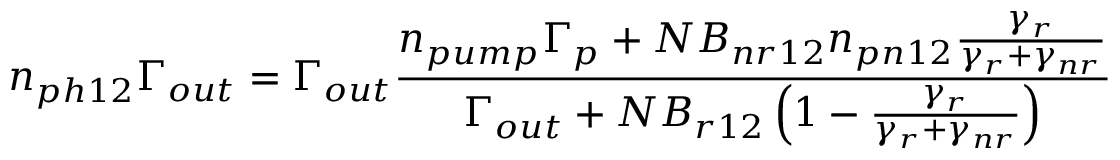<formula> <loc_0><loc_0><loc_500><loc_500>n _ { p h 1 2 } \Gamma _ { o u t } = \Gamma _ { o u t } \frac { n _ { p u m p } \Gamma _ { p } + N B _ { n r 1 2 } n _ { p n 1 2 } \frac { \gamma _ { r } } { \gamma _ { r } + \gamma _ { n r } } } { \Gamma _ { o u t } + N B _ { r 1 2 } \left ( 1 - \frac { \gamma _ { r } } { \gamma _ { r } + \gamma _ { n r } } \right ) }</formula> 